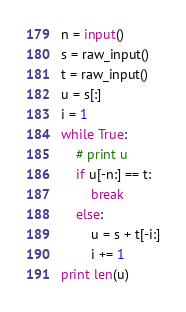<code> <loc_0><loc_0><loc_500><loc_500><_Python_>n = input()
s = raw_input()
t = raw_input()
u = s[:]
i = 1
while True:
    # print u
    if u[-n:] == t:
        break
    else:
        u = s + t[-i:]
        i += 1
print len(u)</code> 